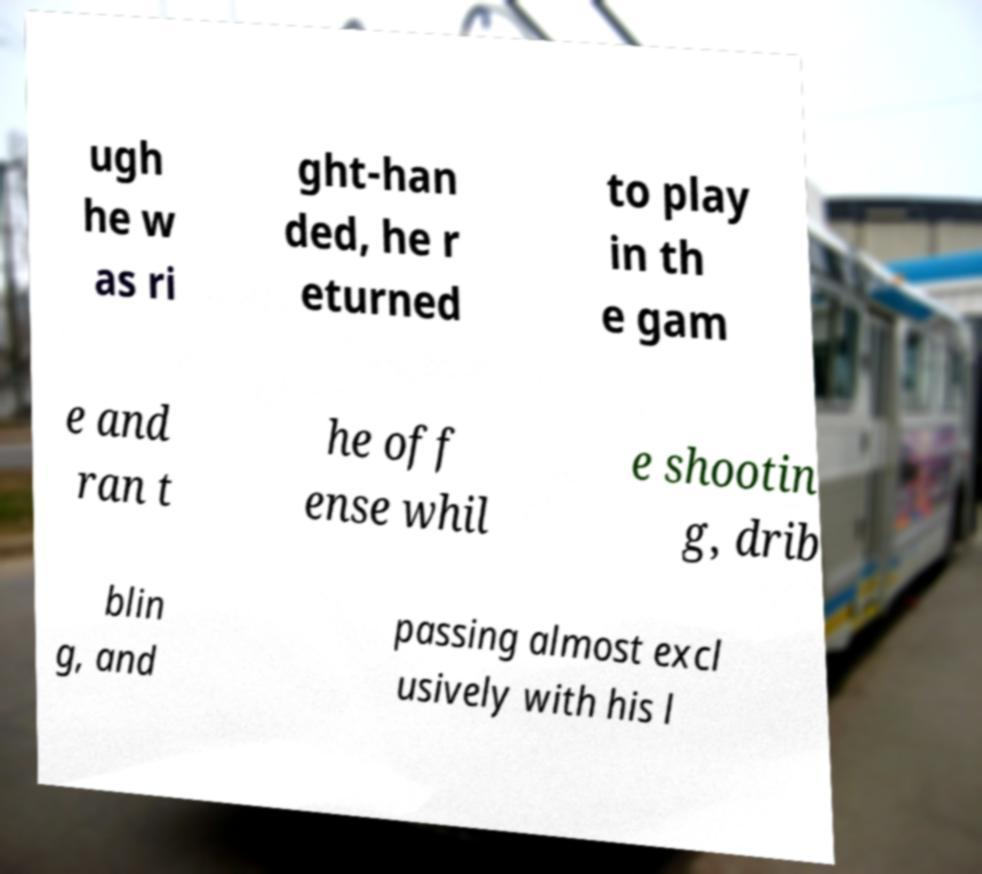Can you read and provide the text displayed in the image?This photo seems to have some interesting text. Can you extract and type it out for me? ugh he w as ri ght-han ded, he r eturned to play in th e gam e and ran t he off ense whil e shootin g, drib blin g, and passing almost excl usively with his l 